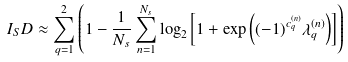<formula> <loc_0><loc_0><loc_500><loc_500>I _ { S } D \approx \sum ^ { 2 } _ { q = 1 } \left ( 1 - \frac { 1 } { N _ { s } } \sum _ { n = 1 } ^ { N _ { s } } \log _ { 2 } \left [ 1 + \exp { \left ( ( - 1 ) ^ { c _ { q } ^ { ( n ) } } \lambda _ { q } ^ { ( n ) } \right ) } \right ] \right )</formula> 